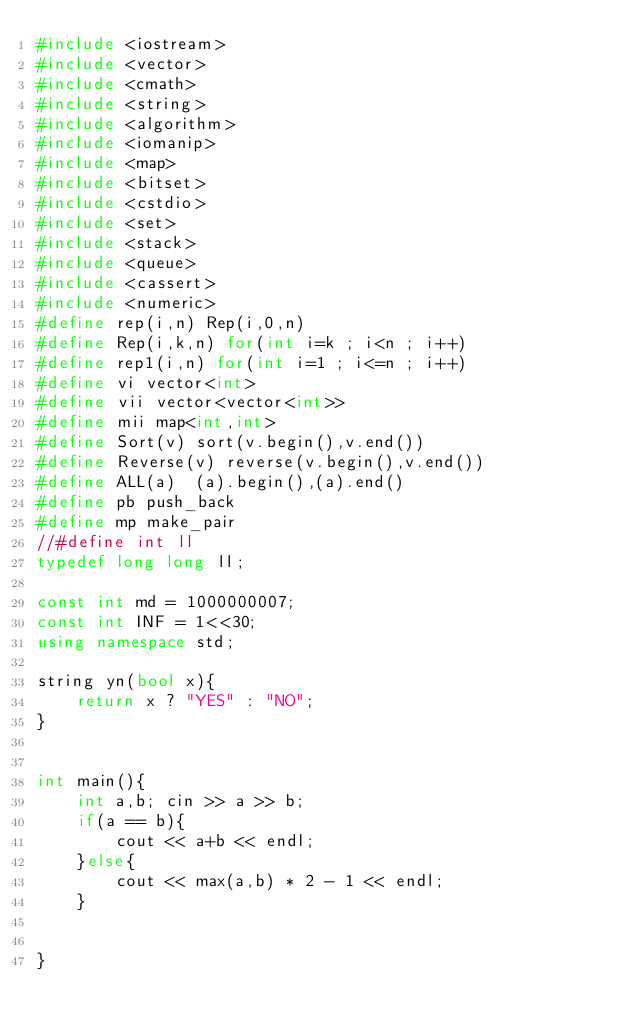<code> <loc_0><loc_0><loc_500><loc_500><_C++_>#include <iostream>
#include <vector>
#include <cmath>
#include <string>
#include <algorithm>
#include <iomanip>
#include <map>
#include <bitset>
#include <cstdio>
#include <set>
#include <stack>
#include <queue>
#include <cassert>
#include <numeric>
#define rep(i,n) Rep(i,0,n)
#define Rep(i,k,n) for(int i=k ; i<n ; i++)
#define rep1(i,n) for(int i=1 ; i<=n ; i++)
#define vi vector<int>
#define vii vector<vector<int>>
#define mii map<int,int>
#define Sort(v) sort(v.begin(),v.end())
#define Reverse(v) reverse(v.begin(),v.end())
#define ALL(a)  (a).begin(),(a).end()
#define pb push_back
#define mp make_pair
//#define int ll
typedef long long ll;

const int md = 1000000007;
const int INF = 1<<30;
using namespace std;

string yn(bool x){
    return x ? "YES" : "NO";
}


int main(){
    int a,b; cin >> a >> b;
    if(a == b){
        cout << a+b << endl;
    }else{
        cout << max(a,b) * 2 - 1 << endl;
    }


}

</code> 